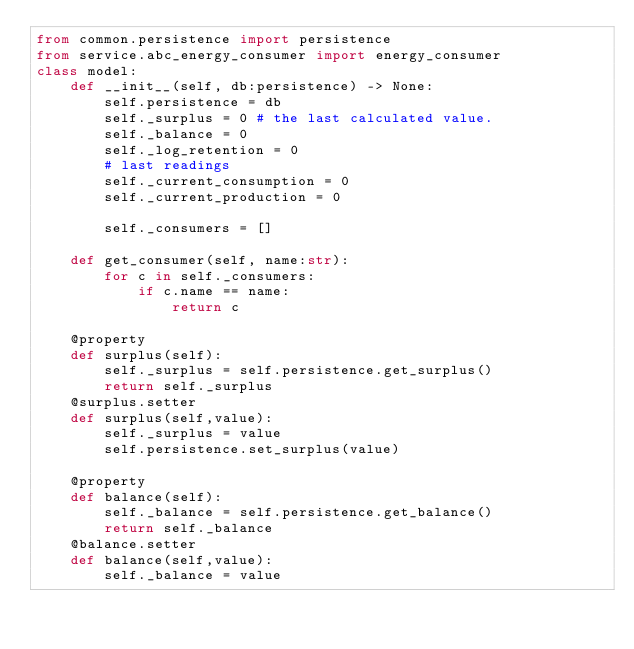<code> <loc_0><loc_0><loc_500><loc_500><_Python_>from common.persistence import persistence
from service.abc_energy_consumer import energy_consumer
class model:
    def __init__(self, db:persistence) -> None:
        self.persistence = db
        self._surplus = 0 # the last calculated value.
        self._balance = 0
        self._log_retention = 0
        # last readings
        self._current_consumption = 0
        self._current_production = 0

        self._consumers = []
        
    def get_consumer(self, name:str):
        for c in self._consumers:
            if c.name == name:
                return c

    @property
    def surplus(self):
        self._surplus = self.persistence.get_surplus()
        return self._surplus
    @surplus.setter
    def surplus(self,value):
        self._surplus = value
        self.persistence.set_surplus(value)

    @property
    def balance(self):
        self._balance = self.persistence.get_balance()
        return self._balance
    @balance.setter
    def balance(self,value):
        self._balance = value</code> 